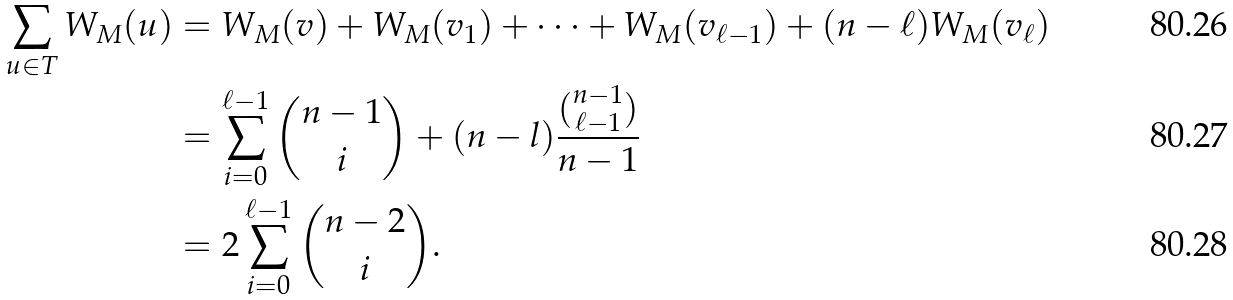<formula> <loc_0><loc_0><loc_500><loc_500>\sum _ { u \in T } W _ { M } ( u ) & = W _ { M } ( v ) + W _ { M } ( v _ { 1 } ) + \cdots + W _ { M } ( v _ { \ell - 1 } ) + ( n - \ell ) W _ { M } ( v _ { \ell } ) \\ & = \sum _ { i = 0 } ^ { \ell - 1 } \binom { n - 1 } { i } + ( n - l ) \frac { \binom { n - 1 } { \ell - 1 } } { n - 1 } \\ & = 2 \sum _ { i = 0 } ^ { \ell - 1 } \binom { n - 2 } { i } .</formula> 